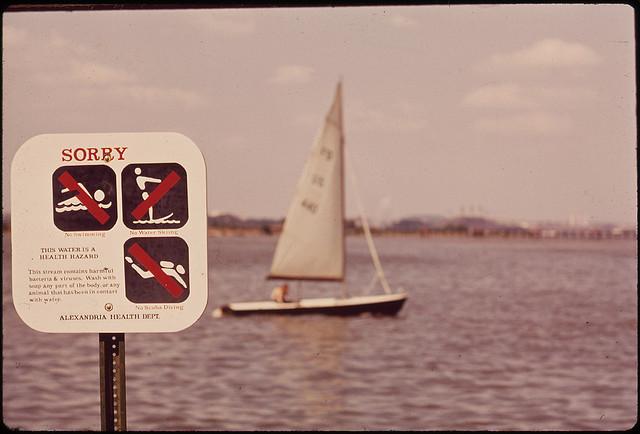What is written on the red sign?
Answer briefly. Sorry. What is the sign saying?
Write a very short answer. Sorry. What can be seen in the upper right corner?
Concise answer only. Cloud. What type of boat is in the water?
Concise answer only. Sail. How many people are on the boat?
Quick response, please. 1. What are you not allowed to do on this lake?
Short answer required. Swim. Do you see trees?
Write a very short answer. No. 